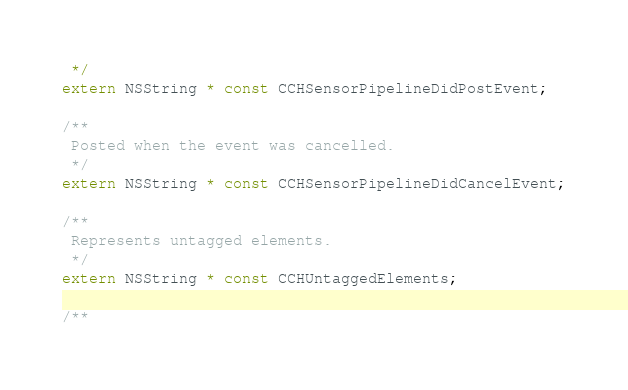Convert code to text. <code><loc_0><loc_0><loc_500><loc_500><_C_> */
extern NSString * const CCHSensorPipelineDidPostEvent;

/**
 Posted when the event was cancelled.
 */
extern NSString * const CCHSensorPipelineDidCancelEvent;

/**
 Represents untagged elements.
 */
extern NSString * const CCHUntaggedElements;

/**</code> 